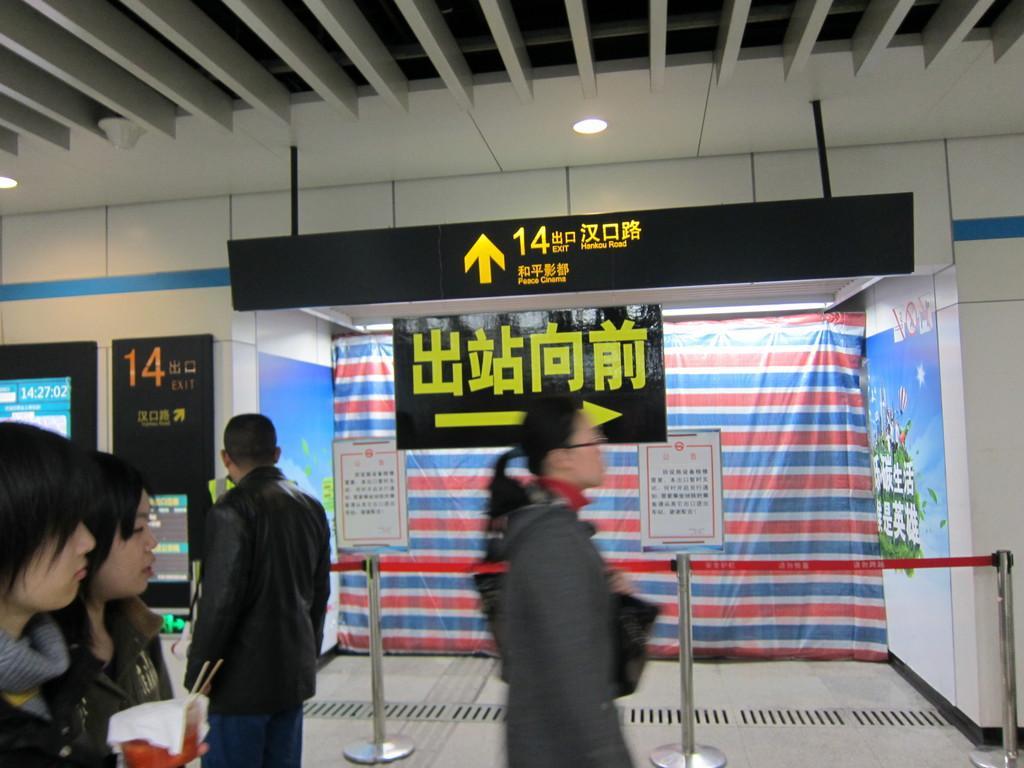In one or two sentences, can you explain what this image depicts? In this image I can see group of people standing. In front the person is wearing black and blue color dress. In the background I can see few poles, boards and I can also see the banner in multi color. 